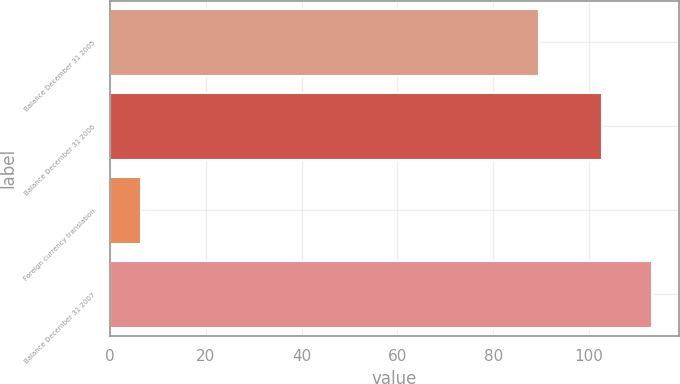<chart> <loc_0><loc_0><loc_500><loc_500><bar_chart><fcel>Balance December 31 2005<fcel>Balance December 31 2006<fcel>Foreign currency translation<fcel>Balance December 31 2007<nl><fcel>89.5<fcel>102.8<fcel>6.4<fcel>113.08<nl></chart> 